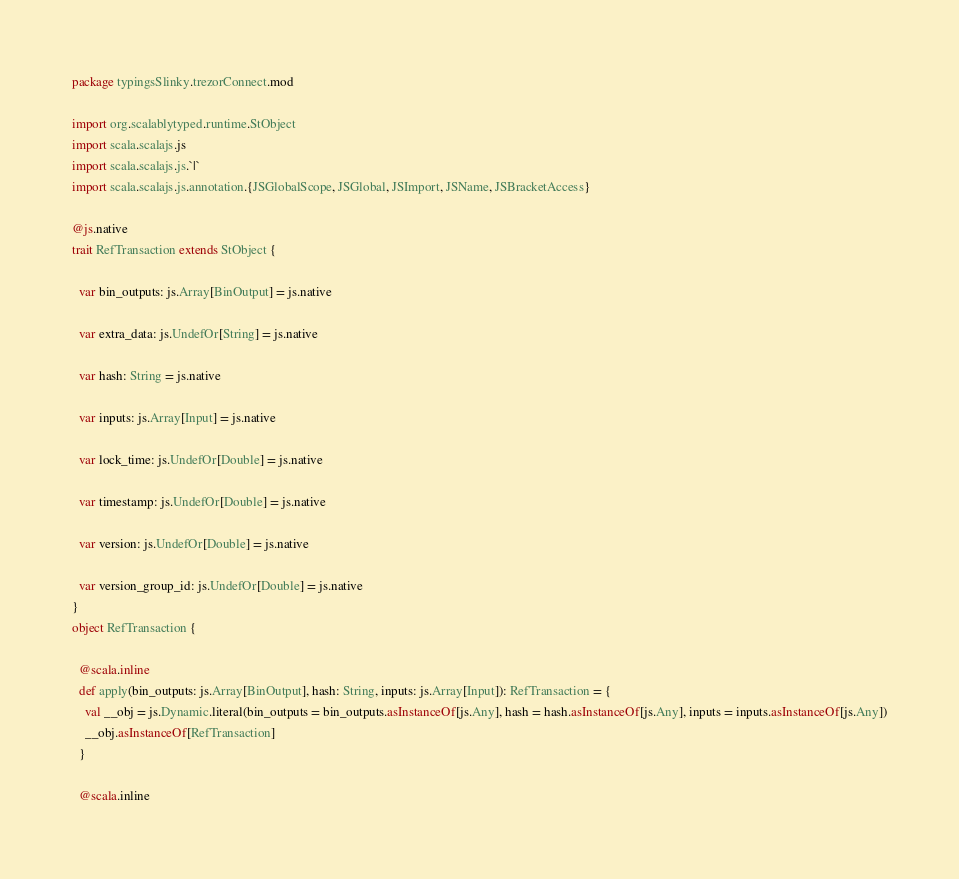<code> <loc_0><loc_0><loc_500><loc_500><_Scala_>package typingsSlinky.trezorConnect.mod

import org.scalablytyped.runtime.StObject
import scala.scalajs.js
import scala.scalajs.js.`|`
import scala.scalajs.js.annotation.{JSGlobalScope, JSGlobal, JSImport, JSName, JSBracketAccess}

@js.native
trait RefTransaction extends StObject {
  
  var bin_outputs: js.Array[BinOutput] = js.native
  
  var extra_data: js.UndefOr[String] = js.native
  
  var hash: String = js.native
  
  var inputs: js.Array[Input] = js.native
  
  var lock_time: js.UndefOr[Double] = js.native
  
  var timestamp: js.UndefOr[Double] = js.native
  
  var version: js.UndefOr[Double] = js.native
  
  var version_group_id: js.UndefOr[Double] = js.native
}
object RefTransaction {
  
  @scala.inline
  def apply(bin_outputs: js.Array[BinOutput], hash: String, inputs: js.Array[Input]): RefTransaction = {
    val __obj = js.Dynamic.literal(bin_outputs = bin_outputs.asInstanceOf[js.Any], hash = hash.asInstanceOf[js.Any], inputs = inputs.asInstanceOf[js.Any])
    __obj.asInstanceOf[RefTransaction]
  }
  
  @scala.inline</code> 